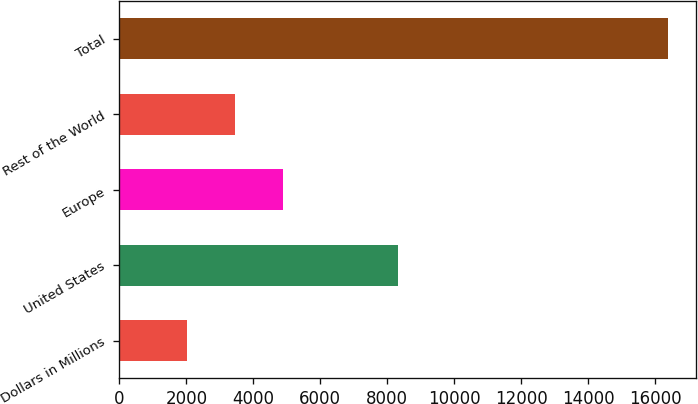<chart> <loc_0><loc_0><loc_500><loc_500><bar_chart><fcel>Dollars in Millions<fcel>United States<fcel>Europe<fcel>Rest of the World<fcel>Total<nl><fcel>2013<fcel>8318<fcel>4887.4<fcel>3450.2<fcel>16385<nl></chart> 